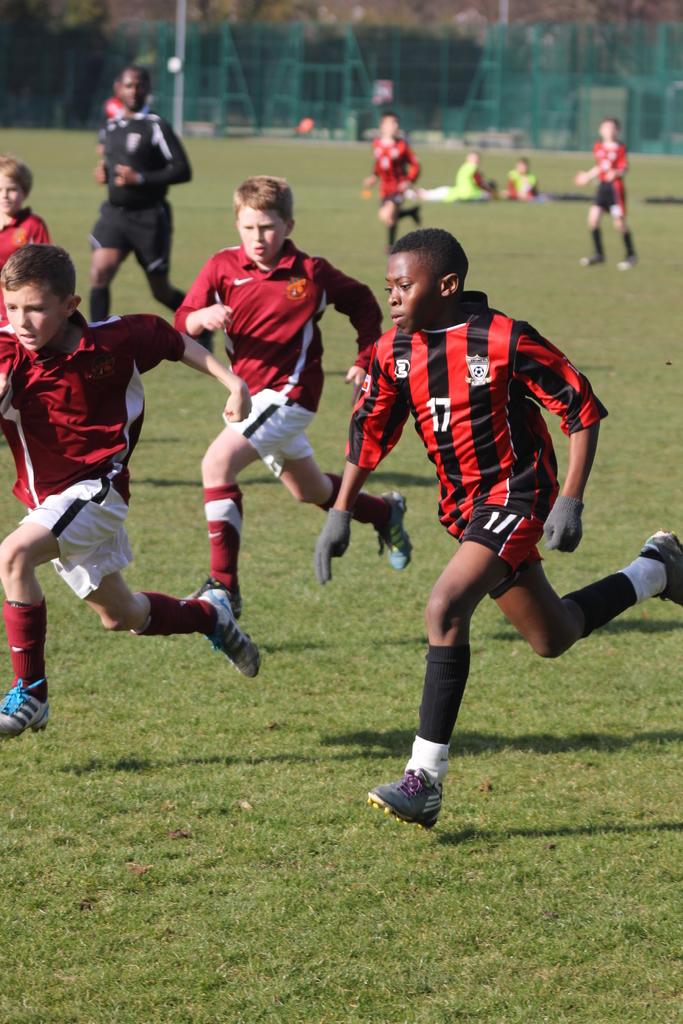What is the boy's player number?
Your answer should be compact. 17. 